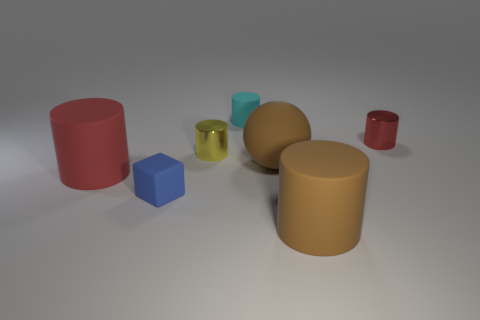Do the colors of the shapes follow a specific pattern? The colors do not follow a traditional sequence like a gradient or a spectrum. However, they are arranged to provide a contrast—a matte red next to a shiny greenish cube, followed by a matte blue, then tan, ending again with a glossy red, suggesting an intentional alternating pattern of matte and glossy finishes. 